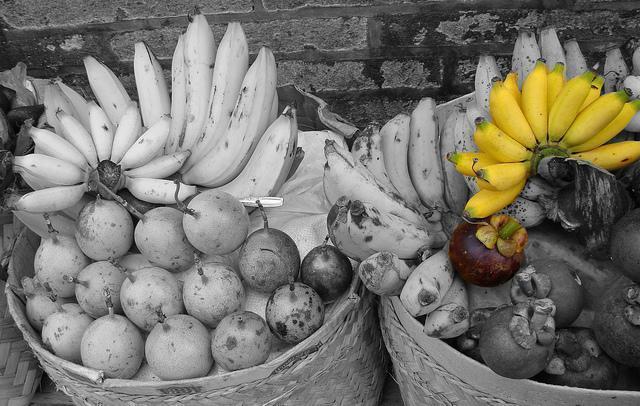How many bananas are in the photo?
Give a very brief answer. 4. How many cups of coffee are in this picture?
Give a very brief answer. 0. 